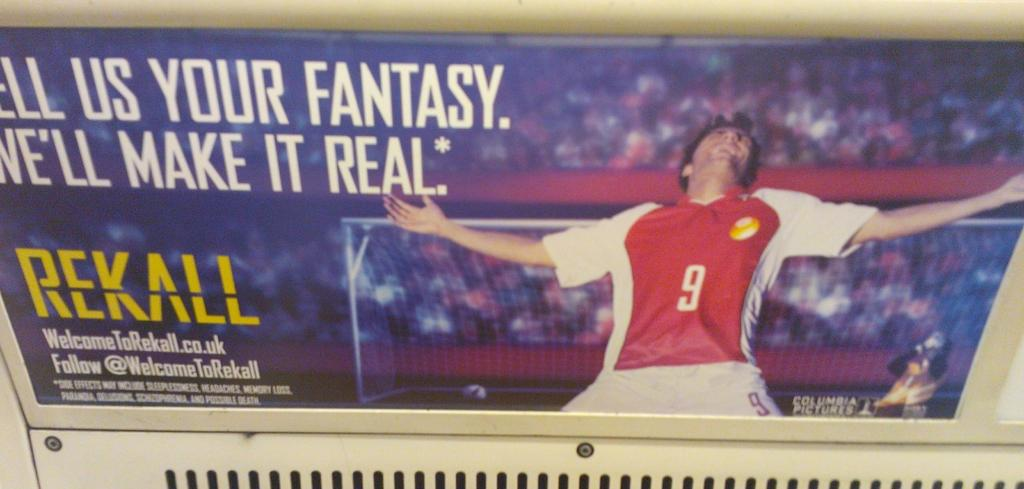<image>
Create a compact narrative representing the image presented. A soccer poster that says, Tell Us Your Fantasy. We'll Make It Real. 